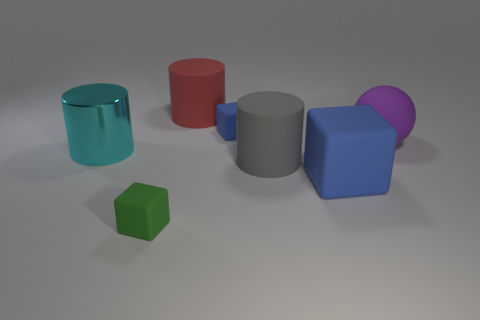What color is the big rubber object that is left of the blue matte block behind the metal object?
Provide a succinct answer. Red. What number of large purple matte balls are there?
Your response must be concise. 1. How many matte objects are yellow cylinders or tiny green objects?
Offer a very short reply. 1. What number of rubber objects have the same color as the big block?
Give a very brief answer. 1. What is the large cylinder that is to the right of the object behind the small blue rubber thing made of?
Offer a very short reply. Rubber. What is the size of the green block?
Give a very brief answer. Small. How many red cylinders are the same size as the cyan cylinder?
Keep it short and to the point. 1. How many red things are the same shape as the small green thing?
Provide a short and direct response. 0. Is the number of big red rubber things in front of the large cyan object the same as the number of large gray matte cylinders?
Provide a short and direct response. No. Is there any other thing that is the same size as the purple sphere?
Provide a short and direct response. Yes. 